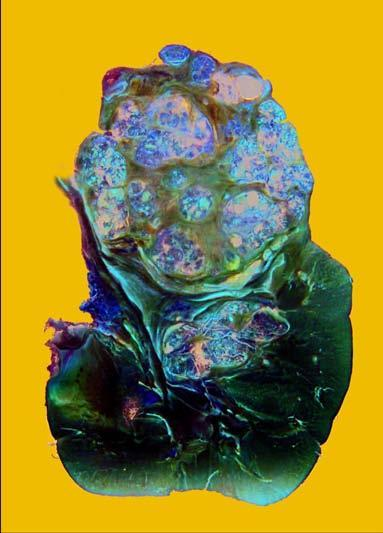how does sectioned surface show?
Answer the question using a single word or phrase. Irregular 